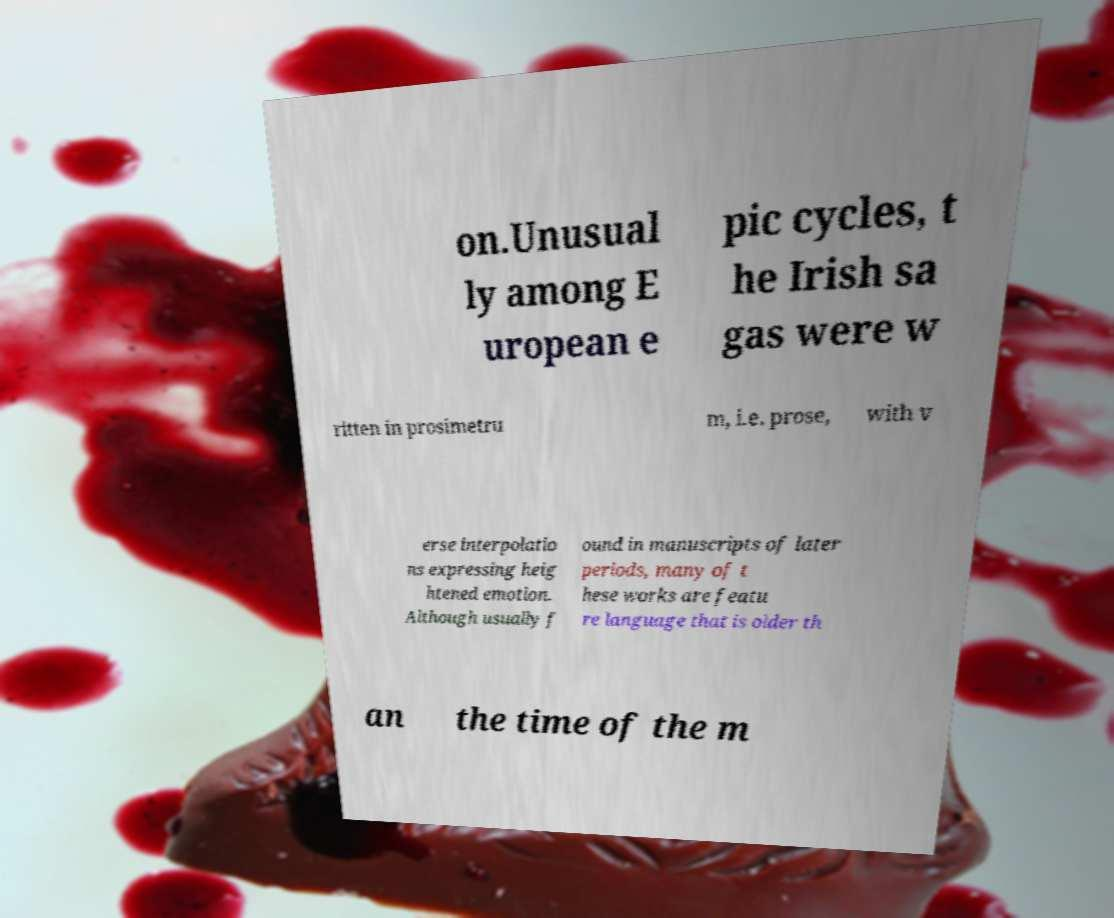Could you extract and type out the text from this image? on.Unusual ly among E uropean e pic cycles, t he Irish sa gas were w ritten in prosimetru m, i.e. prose, with v erse interpolatio ns expressing heig htened emotion. Although usually f ound in manuscripts of later periods, many of t hese works are featu re language that is older th an the time of the m 